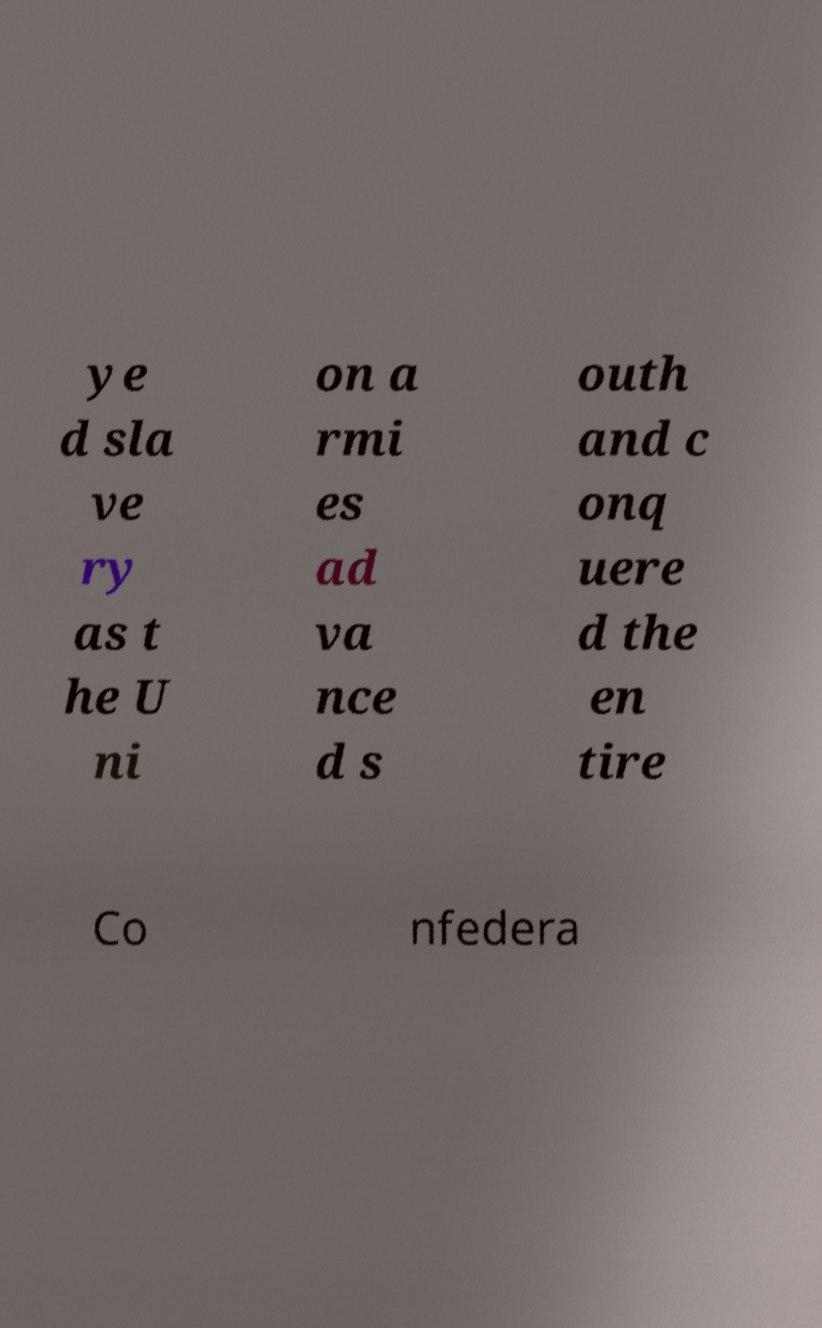What messages or text are displayed in this image? I need them in a readable, typed format. ye d sla ve ry as t he U ni on a rmi es ad va nce d s outh and c onq uere d the en tire Co nfedera 